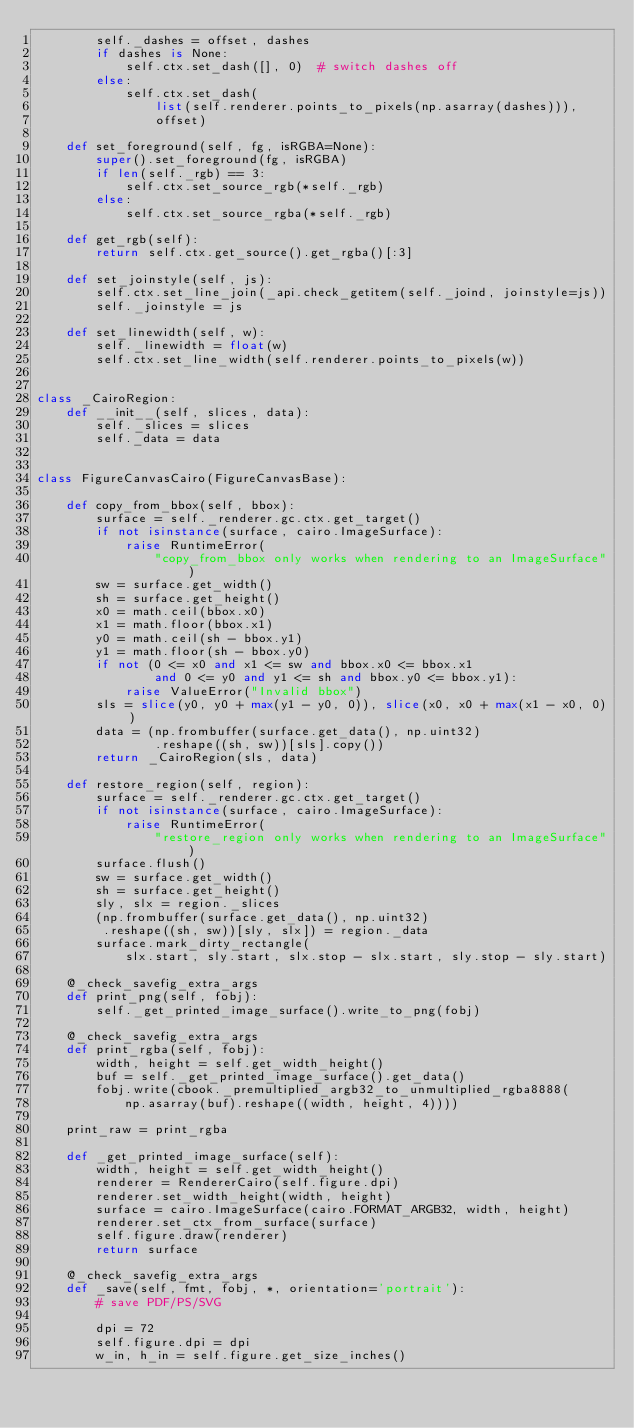<code> <loc_0><loc_0><loc_500><loc_500><_Python_>        self._dashes = offset, dashes
        if dashes is None:
            self.ctx.set_dash([], 0)  # switch dashes off
        else:
            self.ctx.set_dash(
                list(self.renderer.points_to_pixels(np.asarray(dashes))),
                offset)

    def set_foreground(self, fg, isRGBA=None):
        super().set_foreground(fg, isRGBA)
        if len(self._rgb) == 3:
            self.ctx.set_source_rgb(*self._rgb)
        else:
            self.ctx.set_source_rgba(*self._rgb)

    def get_rgb(self):
        return self.ctx.get_source().get_rgba()[:3]

    def set_joinstyle(self, js):
        self.ctx.set_line_join(_api.check_getitem(self._joind, joinstyle=js))
        self._joinstyle = js

    def set_linewidth(self, w):
        self._linewidth = float(w)
        self.ctx.set_line_width(self.renderer.points_to_pixels(w))


class _CairoRegion:
    def __init__(self, slices, data):
        self._slices = slices
        self._data = data


class FigureCanvasCairo(FigureCanvasBase):

    def copy_from_bbox(self, bbox):
        surface = self._renderer.gc.ctx.get_target()
        if not isinstance(surface, cairo.ImageSurface):
            raise RuntimeError(
                "copy_from_bbox only works when rendering to an ImageSurface")
        sw = surface.get_width()
        sh = surface.get_height()
        x0 = math.ceil(bbox.x0)
        x1 = math.floor(bbox.x1)
        y0 = math.ceil(sh - bbox.y1)
        y1 = math.floor(sh - bbox.y0)
        if not (0 <= x0 and x1 <= sw and bbox.x0 <= bbox.x1
                and 0 <= y0 and y1 <= sh and bbox.y0 <= bbox.y1):
            raise ValueError("Invalid bbox")
        sls = slice(y0, y0 + max(y1 - y0, 0)), slice(x0, x0 + max(x1 - x0, 0))
        data = (np.frombuffer(surface.get_data(), np.uint32)
                .reshape((sh, sw))[sls].copy())
        return _CairoRegion(sls, data)

    def restore_region(self, region):
        surface = self._renderer.gc.ctx.get_target()
        if not isinstance(surface, cairo.ImageSurface):
            raise RuntimeError(
                "restore_region only works when rendering to an ImageSurface")
        surface.flush()
        sw = surface.get_width()
        sh = surface.get_height()
        sly, slx = region._slices
        (np.frombuffer(surface.get_data(), np.uint32)
         .reshape((sh, sw))[sly, slx]) = region._data
        surface.mark_dirty_rectangle(
            slx.start, sly.start, slx.stop - slx.start, sly.stop - sly.start)

    @_check_savefig_extra_args
    def print_png(self, fobj):
        self._get_printed_image_surface().write_to_png(fobj)

    @_check_savefig_extra_args
    def print_rgba(self, fobj):
        width, height = self.get_width_height()
        buf = self._get_printed_image_surface().get_data()
        fobj.write(cbook._premultiplied_argb32_to_unmultiplied_rgba8888(
            np.asarray(buf).reshape((width, height, 4))))

    print_raw = print_rgba

    def _get_printed_image_surface(self):
        width, height = self.get_width_height()
        renderer = RendererCairo(self.figure.dpi)
        renderer.set_width_height(width, height)
        surface = cairo.ImageSurface(cairo.FORMAT_ARGB32, width, height)
        renderer.set_ctx_from_surface(surface)
        self.figure.draw(renderer)
        return surface

    @_check_savefig_extra_args
    def _save(self, fmt, fobj, *, orientation='portrait'):
        # save PDF/PS/SVG

        dpi = 72
        self.figure.dpi = dpi
        w_in, h_in = self.figure.get_size_inches()</code> 